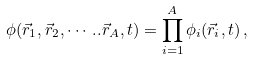Convert formula to latex. <formula><loc_0><loc_0><loc_500><loc_500>\phi ( \vec { r } _ { 1 } , \vec { r } _ { 2 } , \cdots . . \vec { r } _ { A } , t ) = \prod _ { i = 1 } ^ { A } \phi _ { i } ( \vec { r } _ { i } , t ) \, ,</formula> 